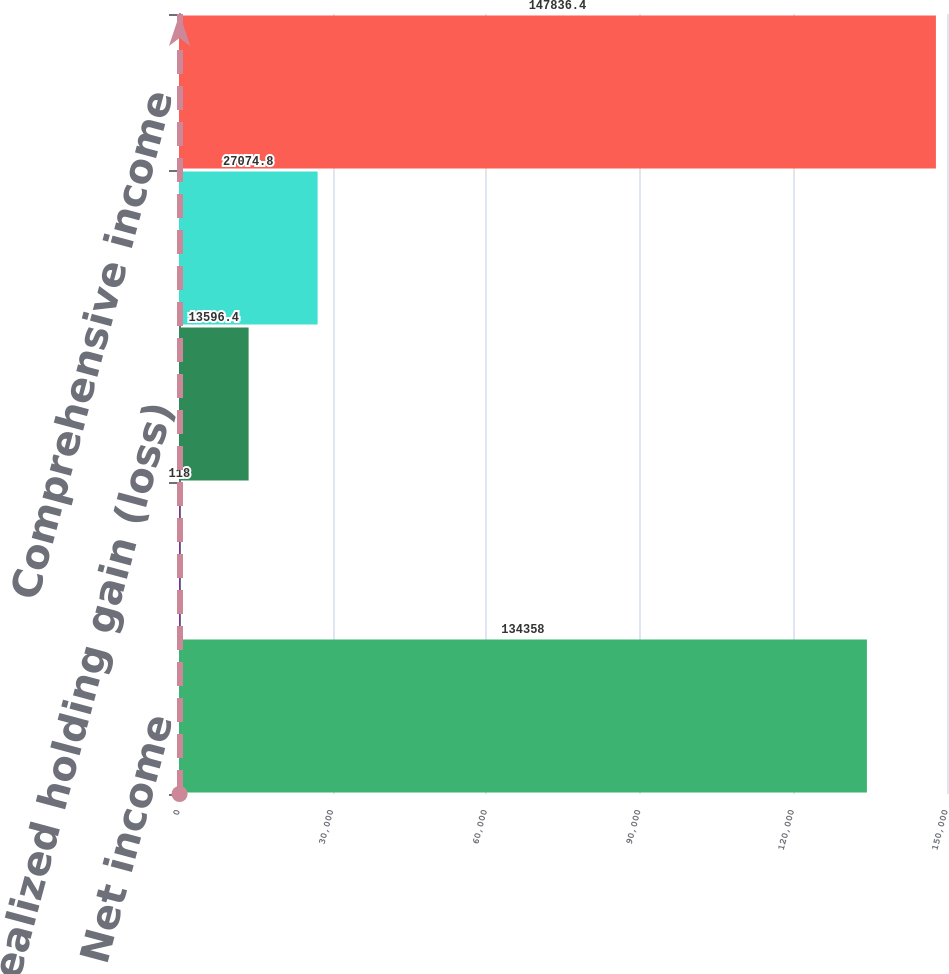<chart> <loc_0><loc_0><loc_500><loc_500><bar_chart><fcel>Net income<fcel>Unrealized gain (loss) on<fcel>Unrealized holding gain (loss)<fcel>Foreign currency translation<fcel>Comprehensive income<nl><fcel>134358<fcel>118<fcel>13596.4<fcel>27074.8<fcel>147836<nl></chart> 